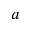<formula> <loc_0><loc_0><loc_500><loc_500>a</formula> 